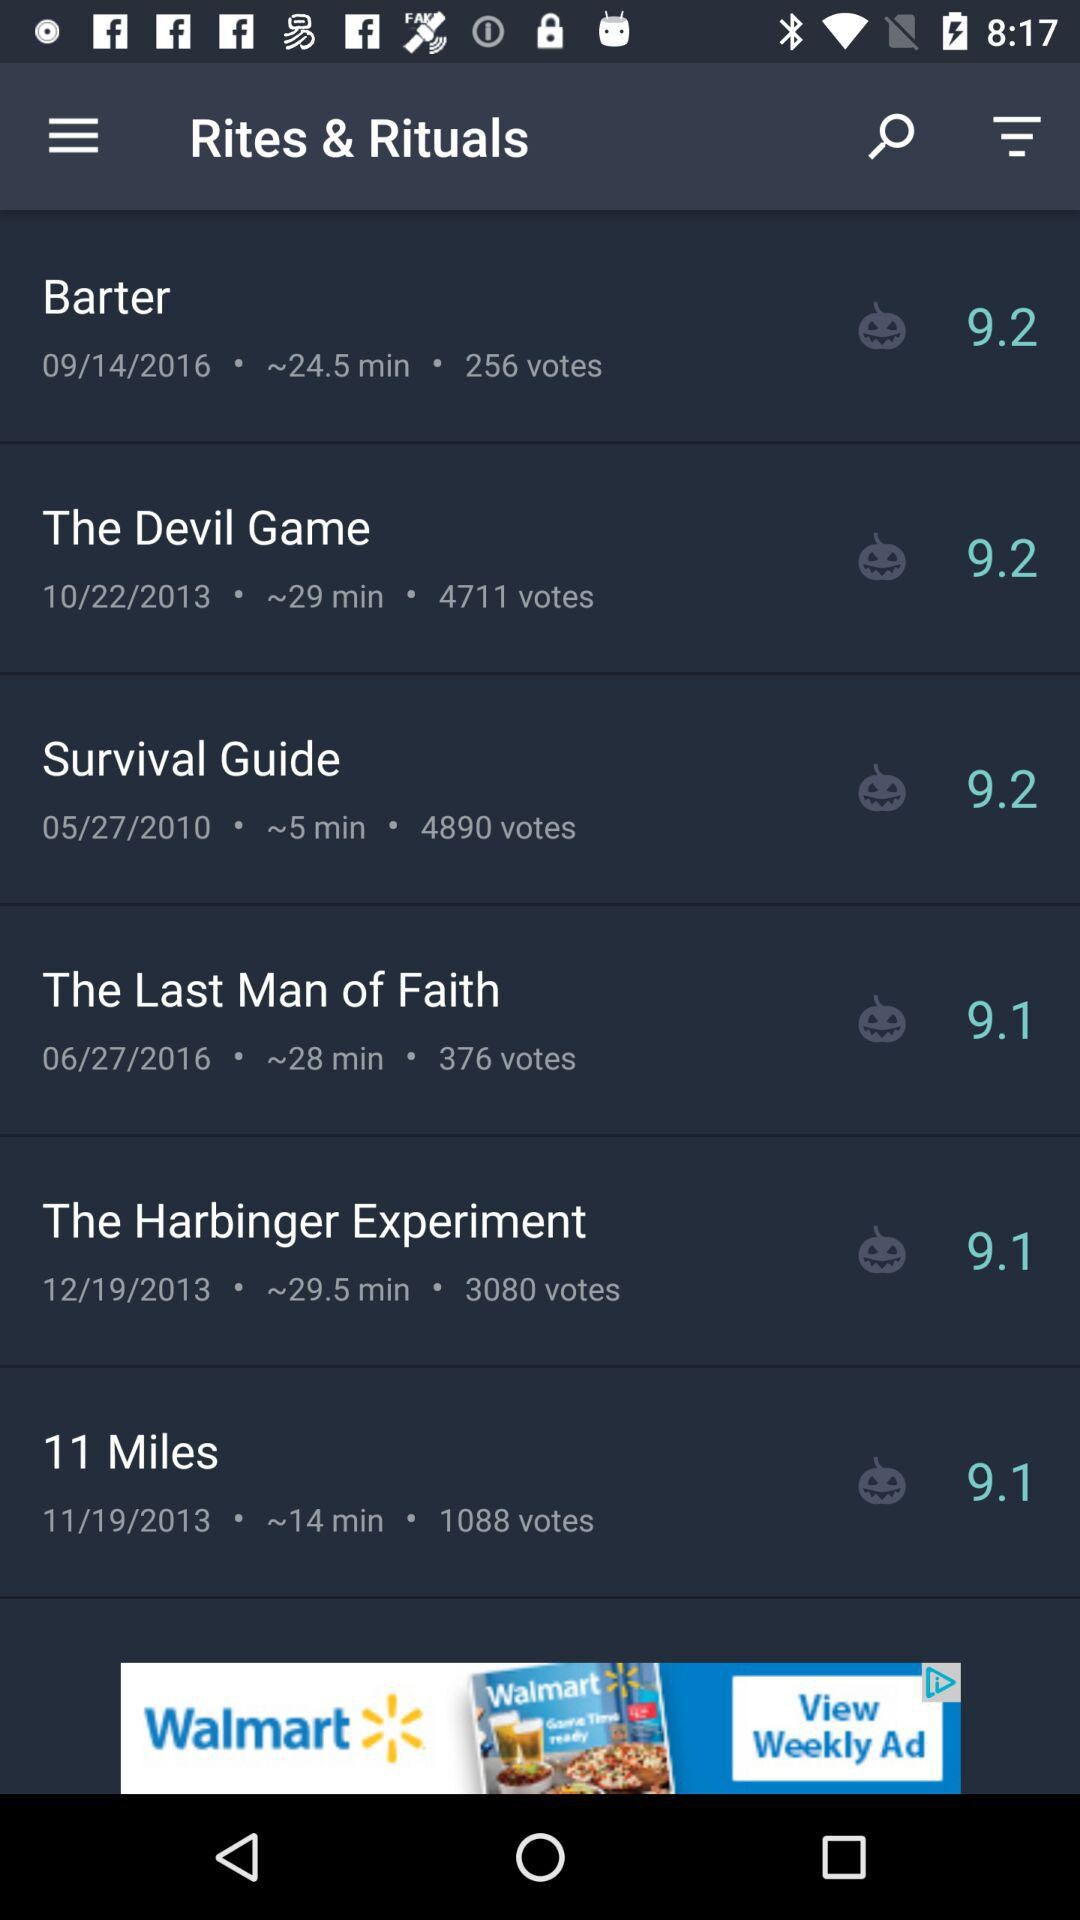What is the rating of "11 Miles"? The rating is 9.1. 